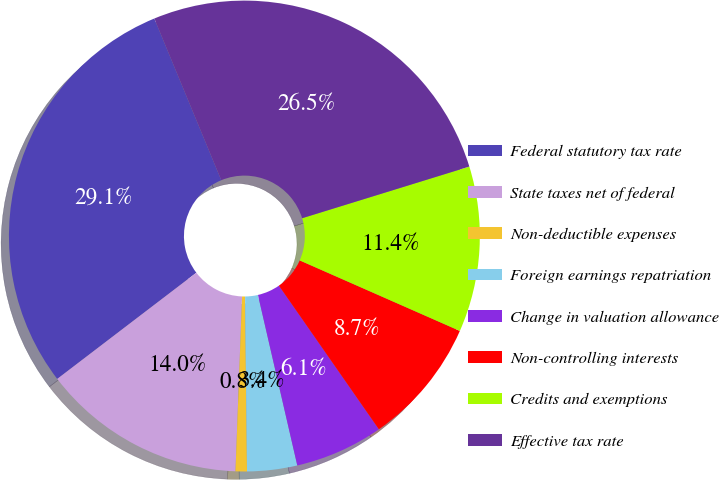Convert chart to OTSL. <chart><loc_0><loc_0><loc_500><loc_500><pie_chart><fcel>Federal statutory tax rate<fcel>State taxes net of federal<fcel>Non-deductible expenses<fcel>Foreign earnings repatriation<fcel>Change in valuation allowance<fcel>Non-controlling interests<fcel>Credits and exemptions<fcel>Effective tax rate<nl><fcel>29.13%<fcel>14.02%<fcel>0.78%<fcel>3.43%<fcel>6.07%<fcel>8.72%<fcel>11.37%<fcel>26.48%<nl></chart> 